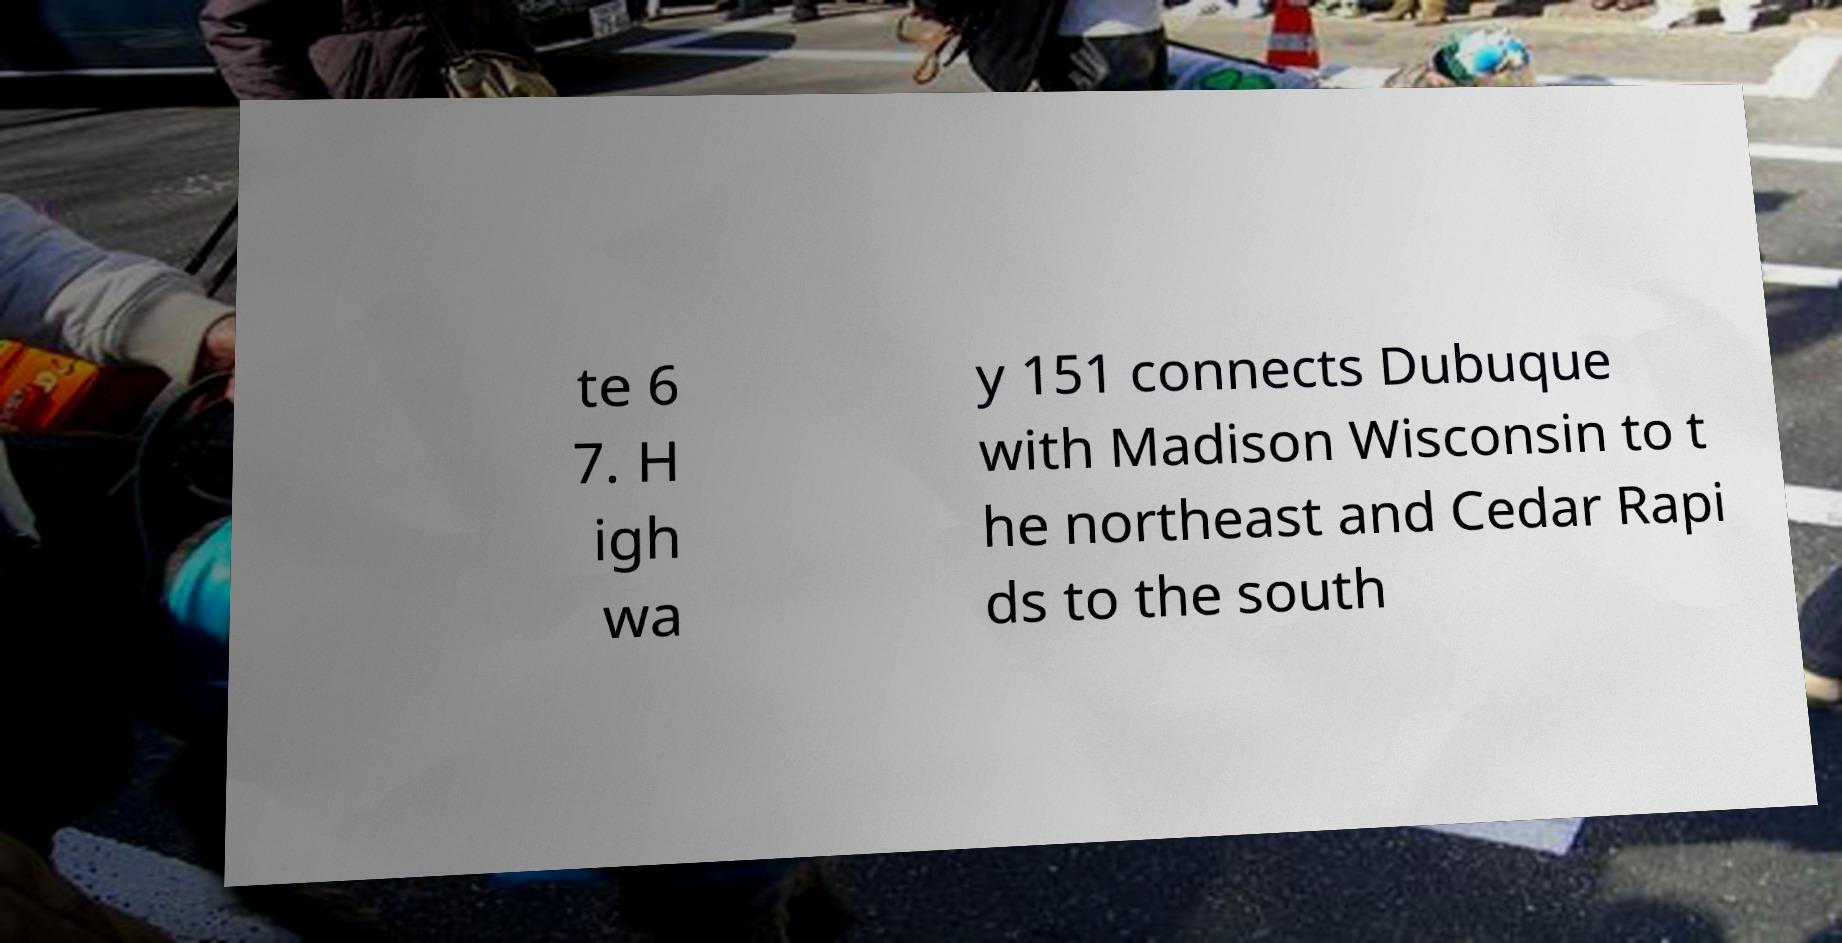What messages or text are displayed in this image? I need them in a readable, typed format. te 6 7. H igh wa y 151 connects Dubuque with Madison Wisconsin to t he northeast and Cedar Rapi ds to the south 